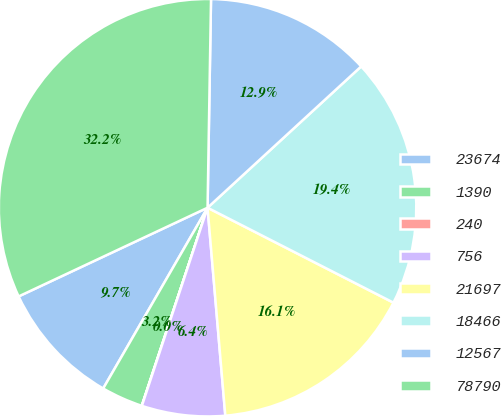Convert chart to OTSL. <chart><loc_0><loc_0><loc_500><loc_500><pie_chart><fcel>23674<fcel>1390<fcel>240<fcel>756<fcel>21697<fcel>18466<fcel>12567<fcel>78790<nl><fcel>9.68%<fcel>3.23%<fcel>0.01%<fcel>6.45%<fcel>16.13%<fcel>19.35%<fcel>12.9%<fcel>32.25%<nl></chart> 